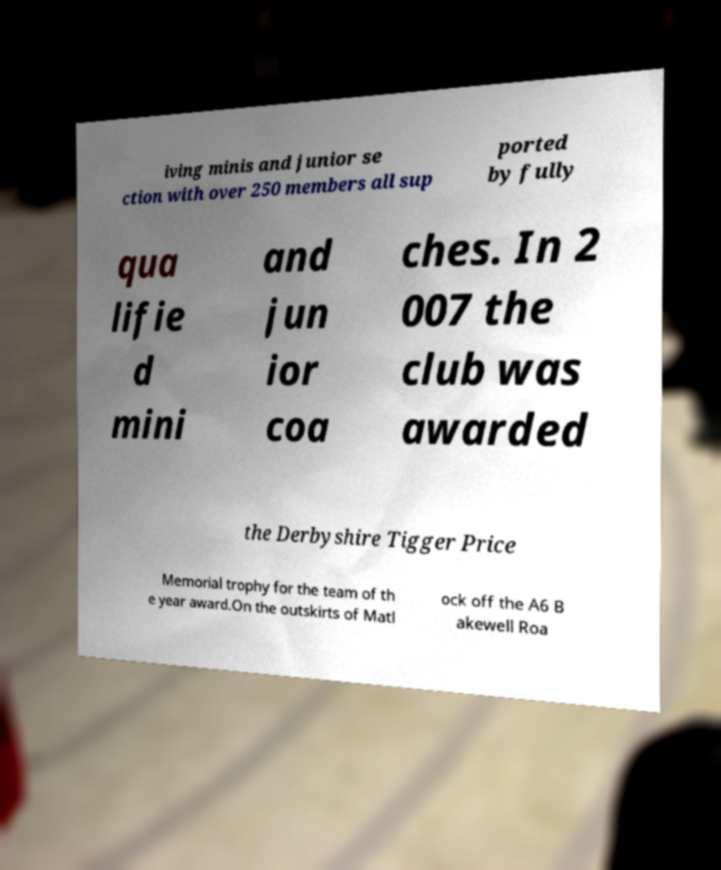What messages or text are displayed in this image? I need them in a readable, typed format. iving minis and junior se ction with over 250 members all sup ported by fully qua lifie d mini and jun ior coa ches. In 2 007 the club was awarded the Derbyshire Tigger Price Memorial trophy for the team of th e year award.On the outskirts of Matl ock off the A6 B akewell Roa 